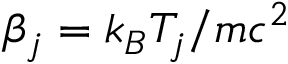Convert formula to latex. <formula><loc_0><loc_0><loc_500><loc_500>\beta _ { j } = k _ { B } T _ { j } / m c ^ { 2 }</formula> 